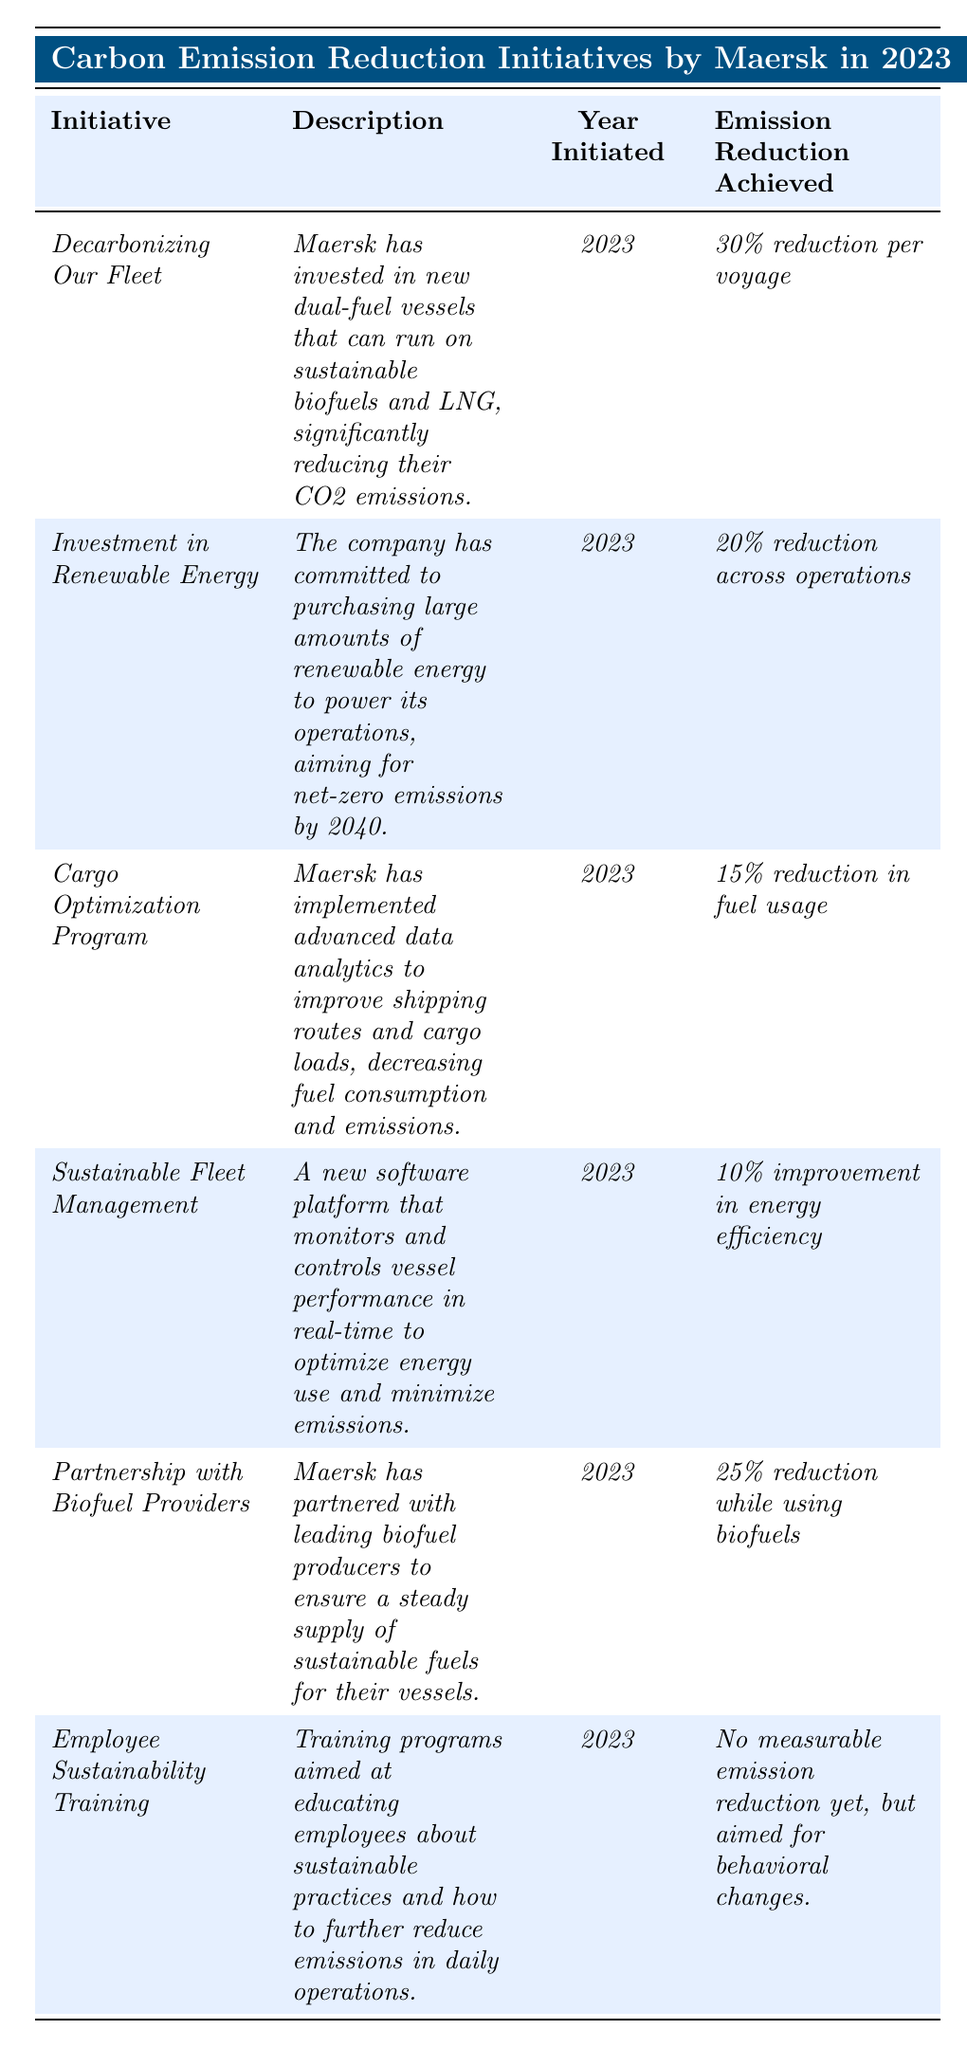What is the initiative that achieved the highest emission reduction per voyage? By checking the "Emission Reduction Achieved" column, the "Decarbonizing Our Fleet" initiative shows a 30% reduction per voyage, which is the highest among all initiatives listed.
Answer: Decarbonizing Our Fleet Which initiative aims for net-zero emissions by 2040? The "Investment in Renewable Energy" initiative describes a commitment to purchasing renewable energy with the goal of achieving net-zero emissions by 2040, as stated in the table.
Answer: Investment in Renewable Energy How much emission reduction is achieved through the Partnership with Biofuel Providers? The table states that the "Partnership with Biofuel Providers" initiative achieves a 25% reduction while using biofuels. Thus, the answer is based on this specific percentage mentioned.
Answer: 25% reduction What is the average reduction in fuel usage achieved by the initiatives listed? By summing the percentage reductions of "Cargo Optimization Program" (15%), "Decarbonizing Our Fleet" (30%), and "Partnership with Biofuel Providers" (25%), we have (15 + 30 + 25) = 70. There are 3 initiatives, so the average is 70 / 3 = 23.33.
Answer: Approximately 23.33% Is there an initiative that has not yet reported a measurable emission reduction? The "Employee Sustainability Training" initiative states it has no measurable emission reduction yet, based on the description in the table. Therefore, this question is answered as a fact-check.
Answer: Yes Which initiative focuses on using data analytics to improve shipping logistics? Referring to the description, the "Cargo Optimization Program" specifically mentions the implementation of advanced data analytics for improving shipping routes and cargo loads.
Answer: Cargo Optimization Program What is the total percentage of emission reductions achieved across initiatives that report a measurable reduction? Adding the measurable reductions: 30% (Decarbonizing Our Fleet) + 20% (Investment in Renewable Energy) + 15% (Cargo Optimization Program) + 10% (Sustainable Fleet Management) + 25% (Partnership with Biofuel Providers) gives a total of 100%.
Answer: 100% Which initiative has the least impact in terms of energy efficiency improvement? By checking the "Emission Reduction Achieved" numbers, "Sustainable Fleet Management" states a 10% improvement, which is lower than any of the other initiatives.
Answer: Sustainable Fleet Management What is one of the goals of the Employee Sustainability Training initiative? The description mentions that the initiative aims to educate employees about sustainable practices and encourages behavioral changes regarding emissions reduction. It doesn't focus on immediate measurable reductions.
Answer: To educate employees about sustainable practices What is the common year for all the initiatives listed? All initiatives have the "Year Initiated" noted as 2023, indicating that they were all launched in the same year.
Answer: 2023 